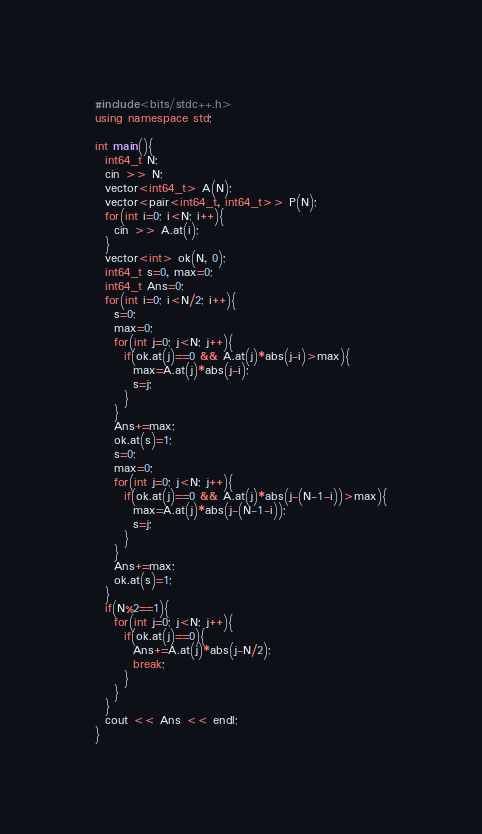Convert code to text. <code><loc_0><loc_0><loc_500><loc_500><_C++_>#include<bits/stdc++.h>
using namespace std;

int main(){
  int64_t N;
  cin >> N;
  vector<int64_t> A(N);
  vector<pair<int64_t, int64_t>> P(N);
  for(int i=0; i<N; i++){
    cin >> A.at(i);
  }
  vector<int> ok(N, 0);
  int64_t s=0, max=0;
  int64_t Ans=0;
  for(int i=0; i<N/2; i++){
    s=0;
    max=0;
    for(int j=0; j<N; j++){
      if(ok.at(j)==0 && A.at(j)*abs(j-i)>max){
        max=A.at(j)*abs(j-i);
        s=j;
      }
    }
    Ans+=max;
    ok.at(s)=1;
    s=0;
    max=0;
    for(int j=0; j<N; j++){
      if(ok.at(j)==0 && A.at(j)*abs(j-(N-1-i))>max){
        max=A.at(j)*abs(j-(N-1-i));
        s=j;
      }
    }
    Ans+=max;
    ok.at(s)=1;
  }
  if(N%2==1){
    for(int j=0; j<N; j++){
      if(ok.at(j)==0){
        Ans+=A.at(j)*abs(j-N/2);
        break;
      }
    }
  }
  cout << Ans << endl;
}</code> 